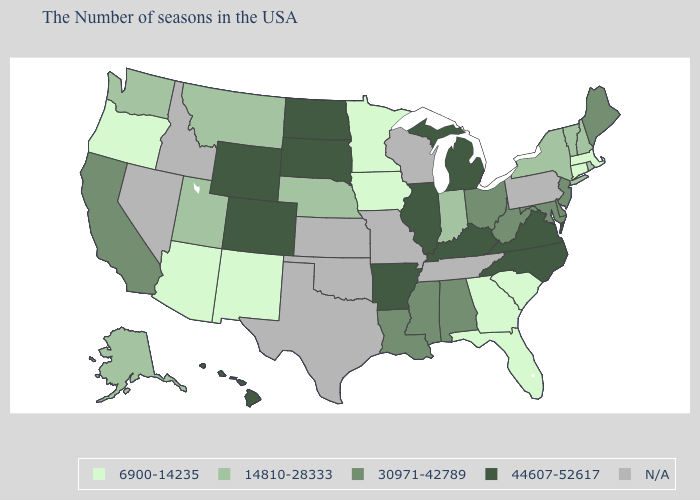What is the value of Utah?
Quick response, please. 14810-28333. Name the states that have a value in the range 30971-42789?
Give a very brief answer. Maine, New Jersey, Delaware, Maryland, West Virginia, Ohio, Alabama, Mississippi, Louisiana, California. Name the states that have a value in the range 14810-28333?
Keep it brief. Rhode Island, New Hampshire, Vermont, New York, Indiana, Nebraska, Utah, Montana, Washington, Alaska. Does the first symbol in the legend represent the smallest category?
Concise answer only. Yes. Among the states that border Nebraska , does Wyoming have the highest value?
Concise answer only. Yes. Does Iowa have the lowest value in the MidWest?
Write a very short answer. Yes. Which states have the lowest value in the USA?
Keep it brief. Massachusetts, Connecticut, South Carolina, Florida, Georgia, Minnesota, Iowa, New Mexico, Arizona, Oregon. What is the highest value in the USA?
Answer briefly. 44607-52617. Does Massachusetts have the lowest value in the Northeast?
Short answer required. Yes. Among the states that border Michigan , does Ohio have the highest value?
Give a very brief answer. Yes. Which states have the highest value in the USA?
Be succinct. Virginia, North Carolina, Michigan, Kentucky, Illinois, Arkansas, South Dakota, North Dakota, Wyoming, Colorado, Hawaii. What is the value of Rhode Island?
Give a very brief answer. 14810-28333. Name the states that have a value in the range 6900-14235?
Give a very brief answer. Massachusetts, Connecticut, South Carolina, Florida, Georgia, Minnesota, Iowa, New Mexico, Arizona, Oregon. Is the legend a continuous bar?
Answer briefly. No. 